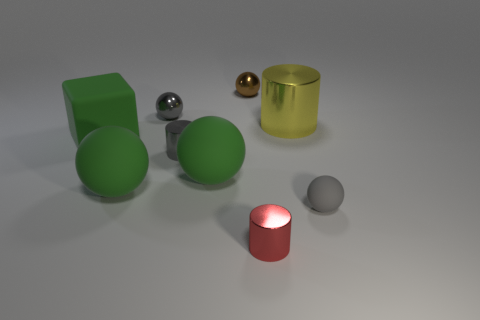What size is the rubber thing that is both on the right side of the small gray shiny ball and left of the brown thing?
Offer a terse response. Large. Is the shape of the gray matte thing the same as the small brown thing?
Your answer should be very brief. Yes. The small gray object that is in front of the small metallic cylinder that is behind the small cylinder that is in front of the small rubber object is what shape?
Your response must be concise. Sphere. Do the small brown object that is on the left side of the gray rubber object and the small gray metal thing behind the yellow cylinder have the same shape?
Your response must be concise. Yes. Are there any brown things that have the same material as the gray cylinder?
Your response must be concise. Yes. What is the color of the matte object that is right of the tiny cylinder that is in front of the gray object in front of the gray cylinder?
Provide a short and direct response. Gray. Are the small gray object behind the rubber cube and the gray ball in front of the big green block made of the same material?
Offer a terse response. No. There is a gray metallic object in front of the cube; what is its shape?
Offer a very short reply. Cylinder. How many things are either small shiny cylinders or large matte objects that are behind the tiny gray cylinder?
Your response must be concise. 3. Are the small brown ball and the gray cylinder made of the same material?
Offer a terse response. Yes. 